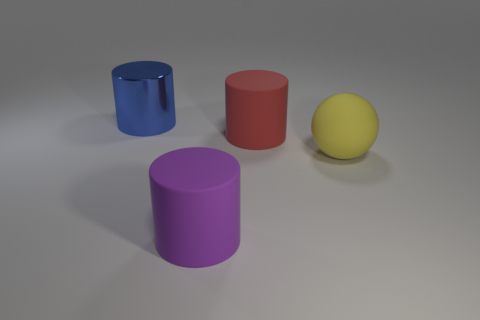Add 2 matte balls. How many objects exist? 6 Subtract all cylinders. How many objects are left? 1 Add 3 yellow rubber balls. How many yellow rubber balls are left? 4 Add 3 big gray objects. How many big gray objects exist? 3 Subtract 0 green balls. How many objects are left? 4 Subtract all large red shiny things. Subtract all big shiny cylinders. How many objects are left? 3 